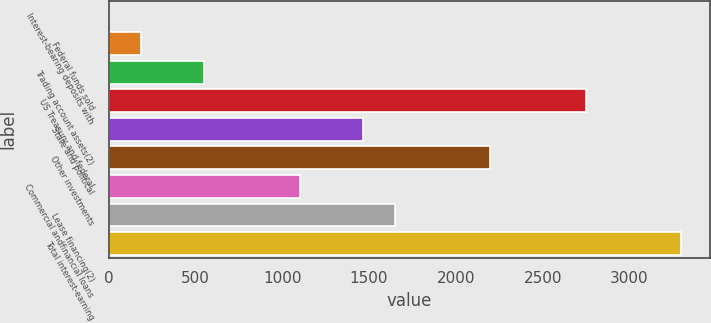<chart> <loc_0><loc_0><loc_500><loc_500><bar_chart><fcel>Interest-bearing deposits with<fcel>Federal funds sold<fcel>Trading account assets(2)<fcel>US Treasury and federal<fcel>State and political<fcel>Other investments<fcel>Commercial andfinancial loans<fcel>Lease financing(2)<fcel>Total interest-earning<nl><fcel>2<fcel>185<fcel>551<fcel>2747<fcel>1466<fcel>2198<fcel>1100<fcel>1649<fcel>3296<nl></chart> 